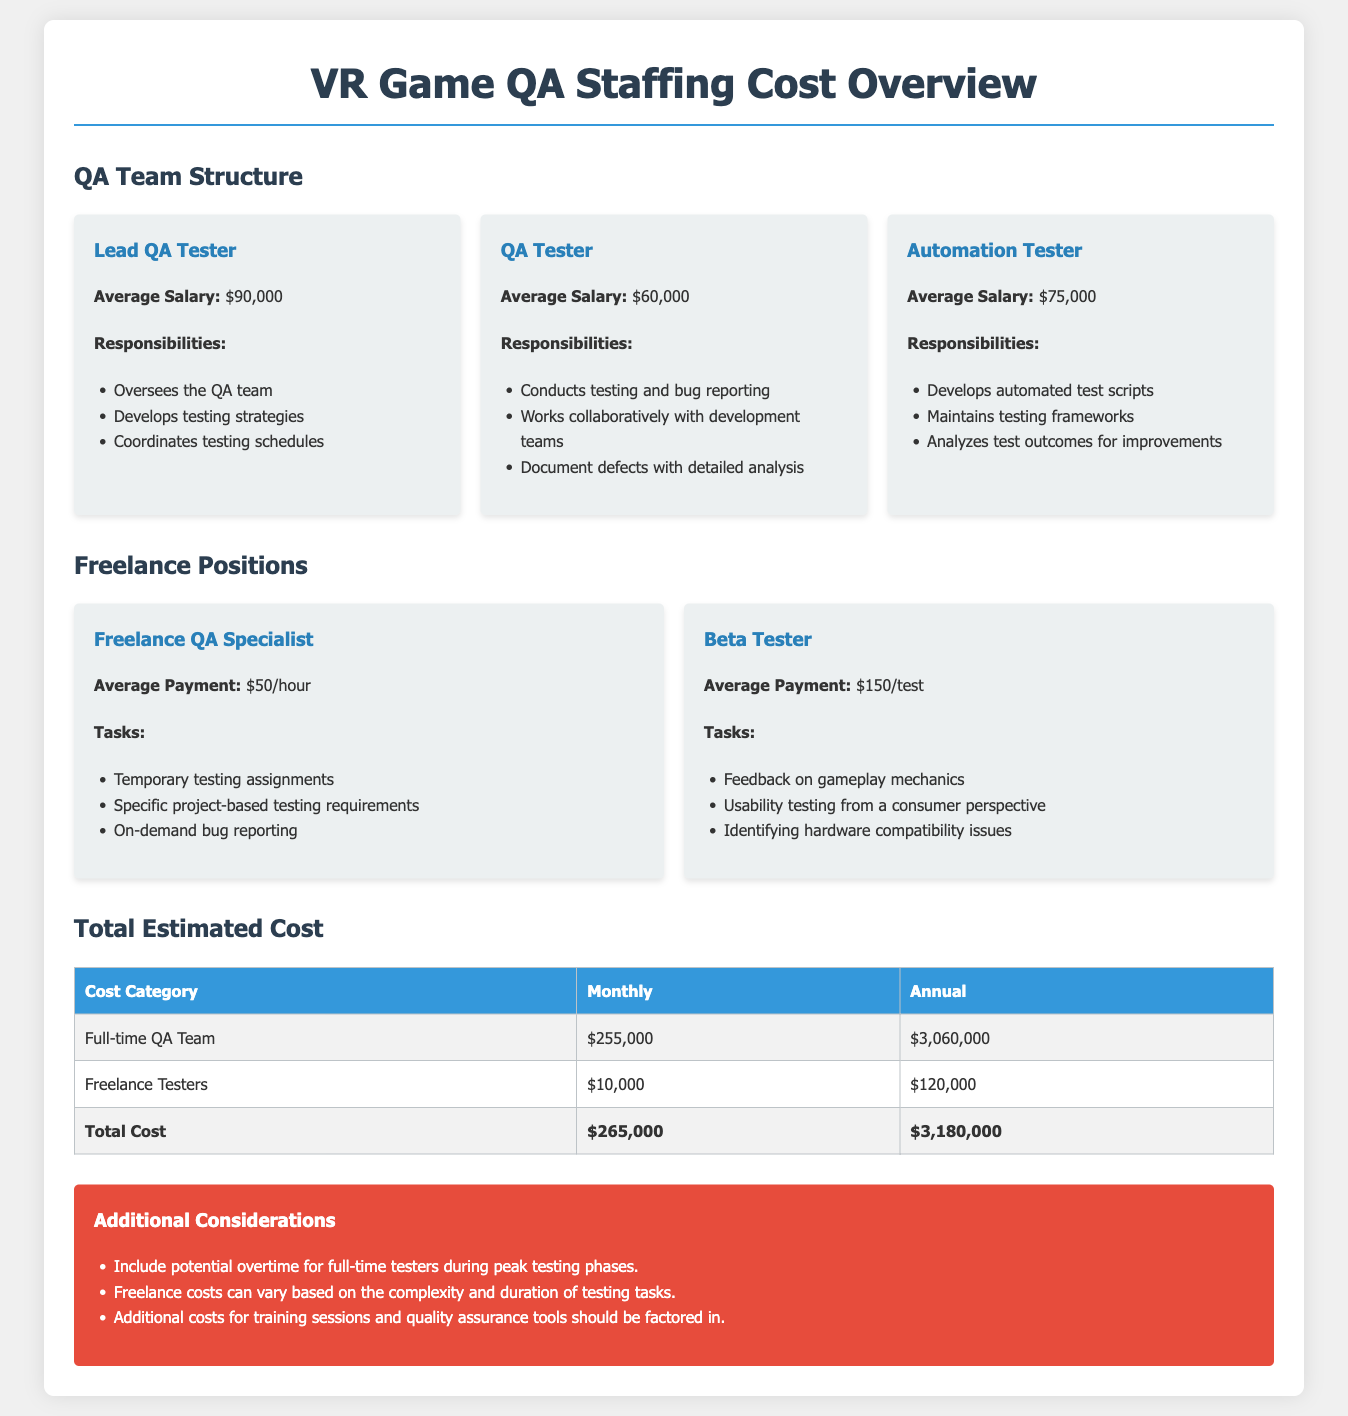What is the average salary of a Lead QA Tester? The average salary of a Lead QA Tester is specified in the document as $90,000.
Answer: $90,000 How much does a Freelance QA Specialist earn per hour? The document states that a Freelance QA Specialist earns $50 per hour.
Answer: $50/hour What is the total estimated cost for the full-time QA team annually? The annual cost for the full-time QA team is indicated as $3,060,000 in the document.
Answer: $3,060,000 How much is the monthly payment for freelance testers? According to the document, the monthly payment for freelance testers is $10,000.
Answer: $10,000 What percentage of the total cost does the full-time QA team account for? The total cost is $265,000, and the cost for the full-time QA team is $255,000, which gives the percentage as 96.23%.
Answer: 96.23% What task does the Automation Tester primarily focus on? The document highlights that the primary focus of the Automation Tester is on developing automated test scripts.
Answer: Developing automated test scripts What are potential additional costs mentioned in the considerations? The considerations mention additional costs for training sessions and quality assurance tools.
Answer: Training sessions and quality assurance tools Who oversees the QA team? The Lead QA Tester is responsible for overseeing the QA team as per the document.
Answer: Lead QA Tester What is the average payment per test for Beta Testers? The document specifies that Beta Testers receive an average payment of $150 per test.
Answer: $150/test 